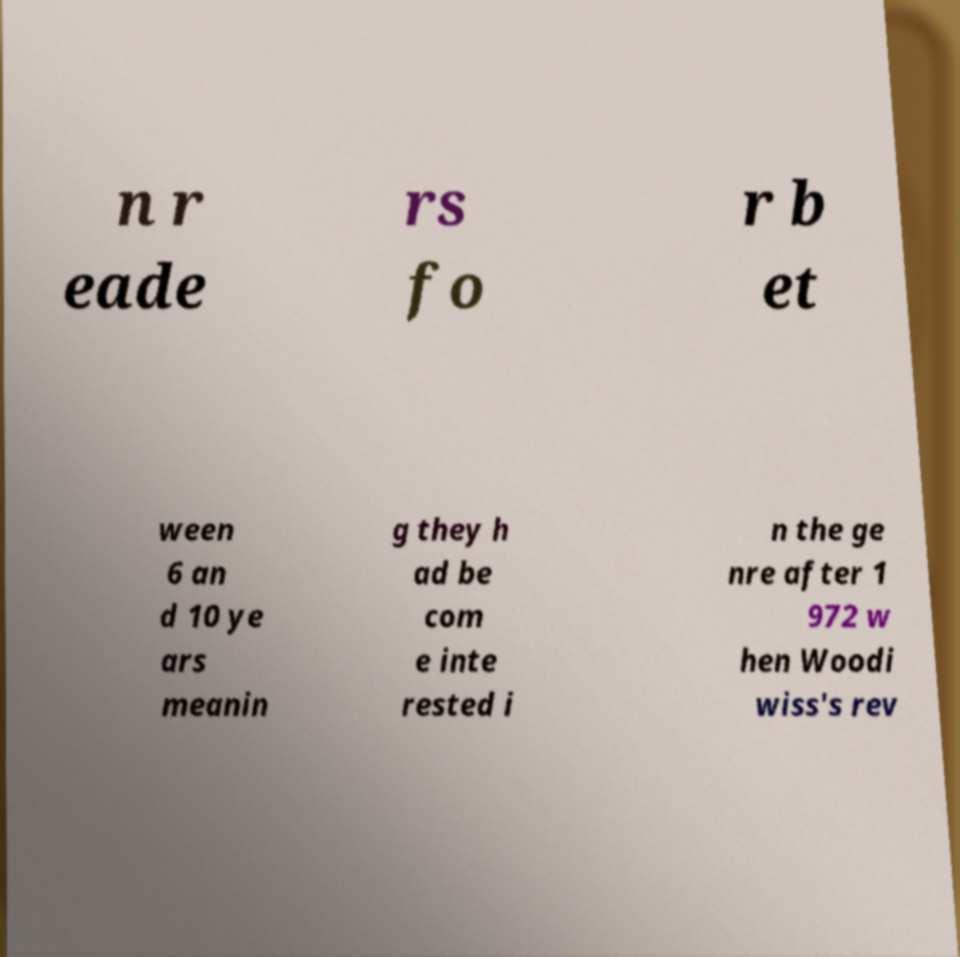Can you read and provide the text displayed in the image?This photo seems to have some interesting text. Can you extract and type it out for me? n r eade rs fo r b et ween 6 an d 10 ye ars meanin g they h ad be com e inte rested i n the ge nre after 1 972 w hen Woodi wiss's rev 